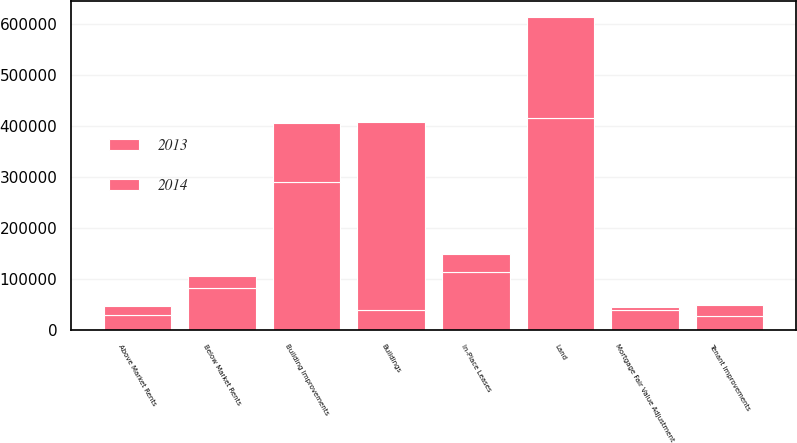<chart> <loc_0><loc_0><loc_500><loc_500><stacked_bar_chart><ecel><fcel>Land<fcel>Buildings<fcel>Below Market Rents<fcel>Above Market Rents<fcel>In-Place Leases<fcel>Building Improvements<fcel>Tenant Improvements<fcel>Mortgage Fair Value Adjustment<nl><fcel>2013<fcel>414879<fcel>39368<fcel>81362<fcel>30307<fcel>113513<fcel>290882<fcel>26536<fcel>39368<nl><fcel>2014<fcel>198263<fcel>368478<fcel>25298<fcel>15758<fcel>35262<fcel>115110<fcel>22196<fcel>5794<nl></chart> 